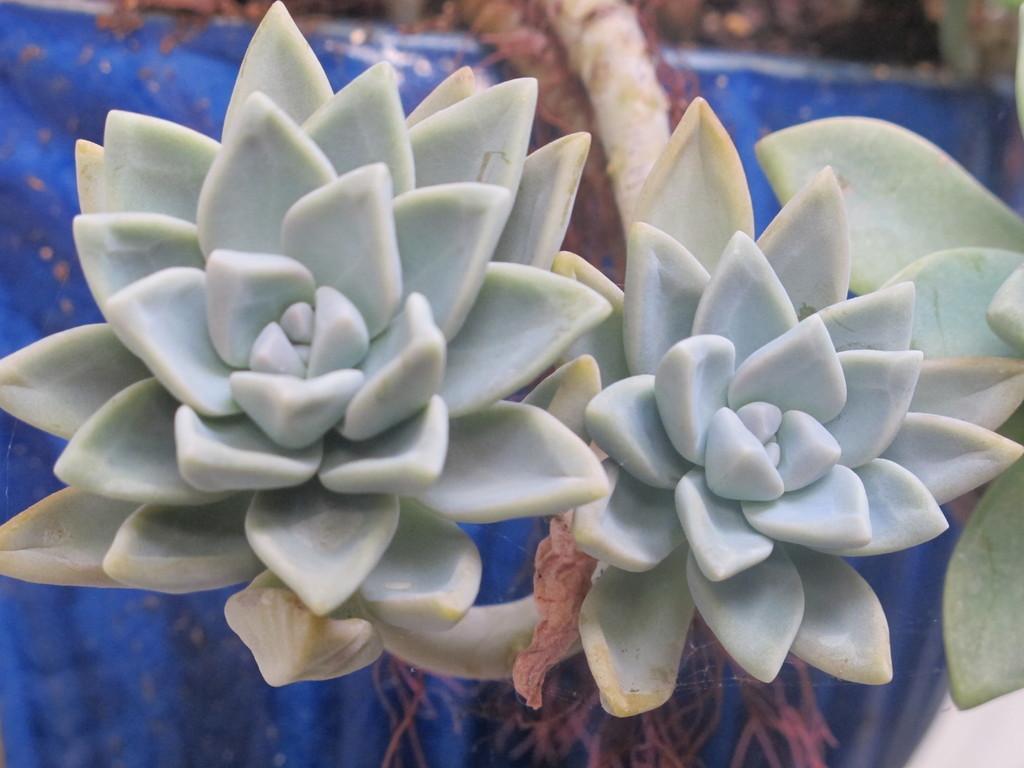Could you give a brief overview of what you see in this image? In this image I can see few flowers which are blue and green in color to a tree. I can see the blue colored background. 